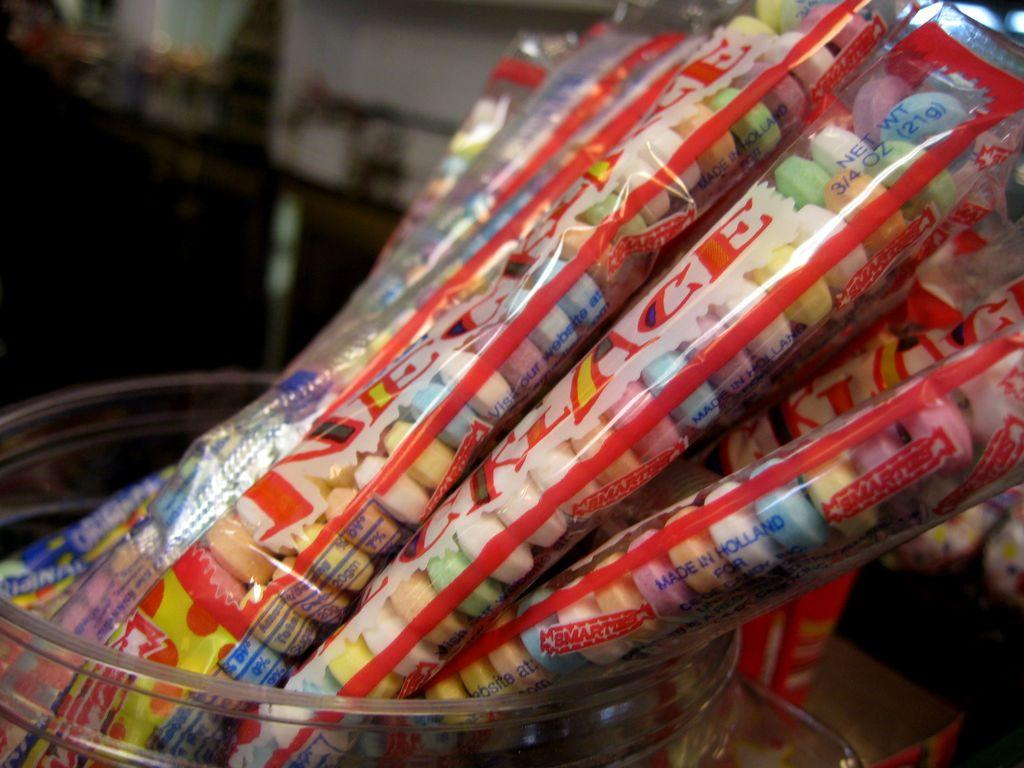What can be found inside the packers in the image? There are colorful objects inside the packers. How are the packers stored or contained in the image? The packers are in a container. Can you describe the background of the image? The background of the image is blurred. What type of brush is being used for teaching on the sofa in the image? There is no brush, teaching, or sofa present in the image. 